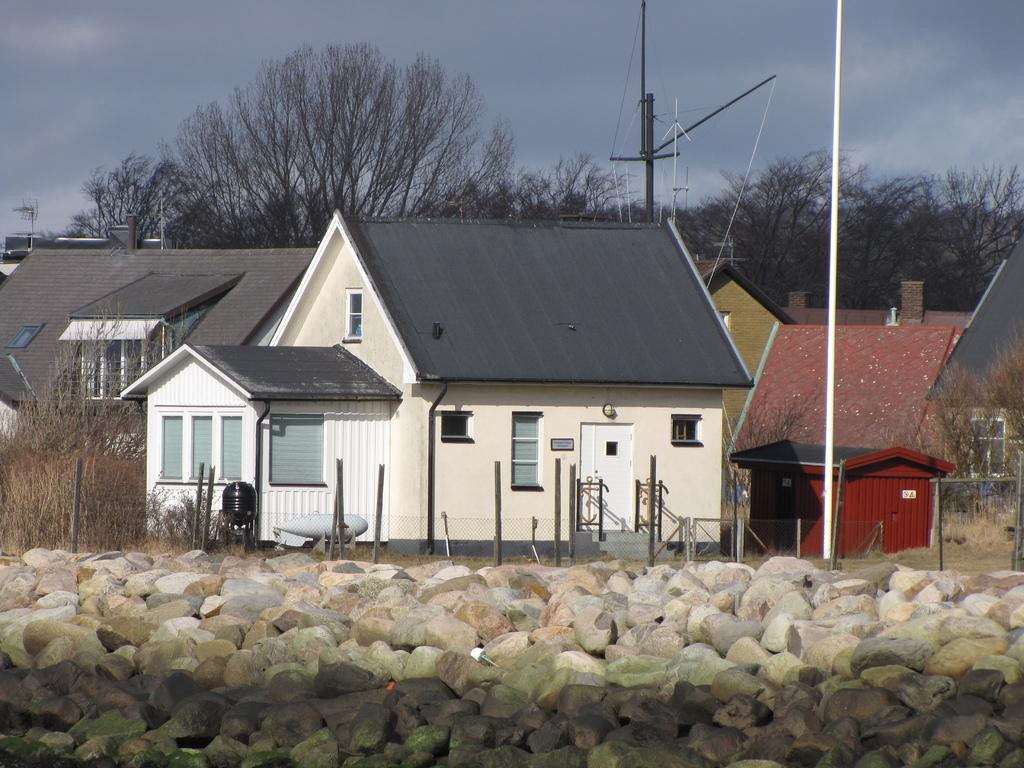What type of objects can be seen in the image? There are stones, poles, houses, trees, light poles, and a shed in the image. Can you describe the natural elements in the image? The image includes trees and the sky, with clouds visible. What type of structures are present in the image? There are houses and a shed in the image. What are the light poles used for in the image? The light poles are likely used for illuminating the area. What type of glass can be seen in the image? There is no glass present in the image. What type of brass object can be seen in the image? There is no brass object present in the image. 